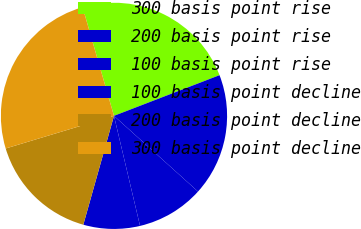Convert chart. <chart><loc_0><loc_0><loc_500><loc_500><pie_chart><fcel>300 basis point rise<fcel>200 basis point rise<fcel>100 basis point rise<fcel>100 basis point decline<fcel>200 basis point decline<fcel>300 basis point decline<nl><fcel>23.62%<fcel>17.52%<fcel>9.63%<fcel>8.07%<fcel>15.97%<fcel>25.18%<nl></chart> 